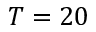<formula> <loc_0><loc_0><loc_500><loc_500>T = 2 0</formula> 